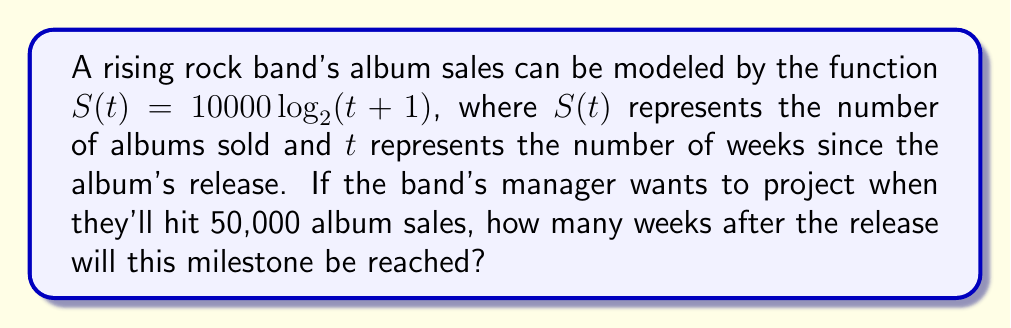Teach me how to tackle this problem. Let's approach this step-by-step:

1) We want to find $t$ when $S(t) = 50000$. So, we need to solve the equation:

   $50000 = 10000 \log_2(t+1)$

2) Divide both sides by 10000:

   $5 = \log_2(t+1)$

3) To solve for $t$, we need to apply the inverse function of $\log_2$, which is $2^x$:

   $2^5 = t+1$

4) Calculate $2^5$:

   $32 = t+1$

5) Subtract 1 from both sides:

   $31 = t$

Therefore, the band will reach 50,000 album sales 31 weeks after the release.
Answer: 31 weeks 